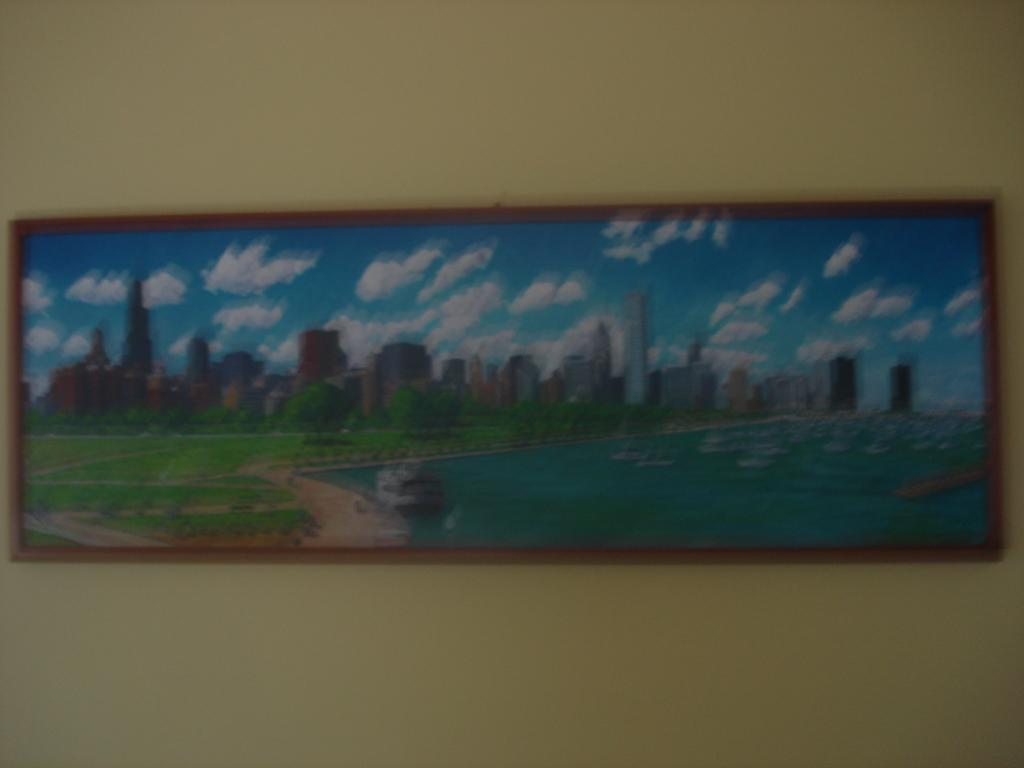What is hanging on the wall in the image? There is a photo frame on the wall in the image. What is depicted in the photo frame? The photo frame contains a picture with buildings, trees, grass, a boat, water, and a cloudy sky. Can you describe the different elements in the picture within the photo frame? The picture within the photo frame includes buildings, trees, grass, a boat, water, and a cloudy sky. How many bears can be seen in the photo frame? There are no bears present in the photo frame; it contains a picture with buildings, trees, grass, a boat, water, and a cloudy sky. What shape is the photo frame in the image? The provided facts do not mention the shape of the photo frame, so it cannot be determined from the image. 